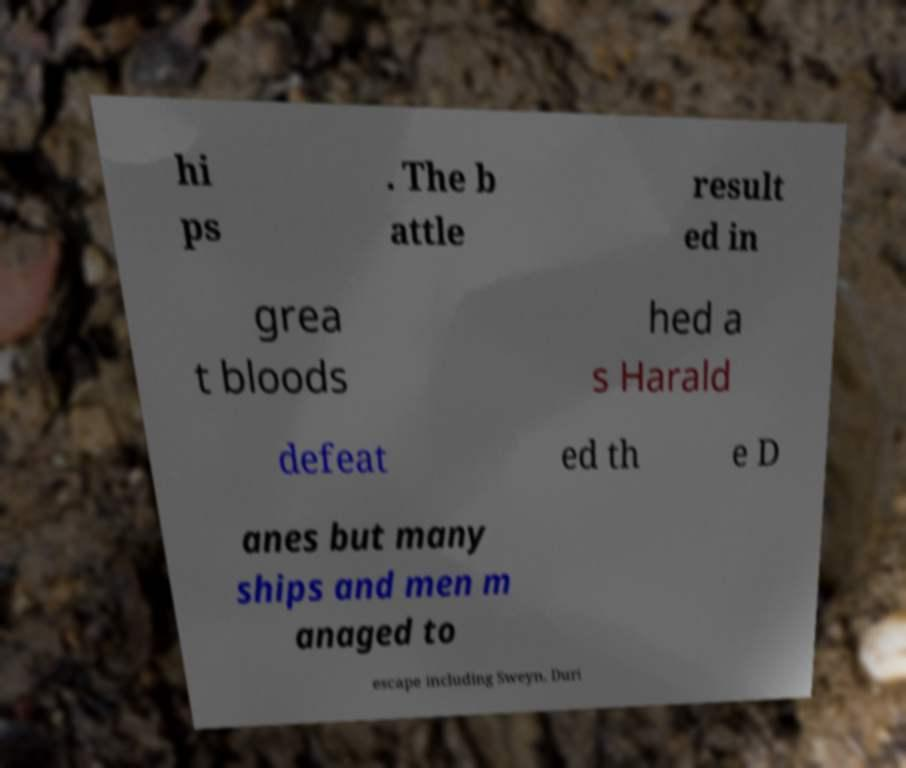What messages or text are displayed in this image? I need them in a readable, typed format. hi ps . The b attle result ed in grea t bloods hed a s Harald defeat ed th e D anes but many ships and men m anaged to escape including Sweyn. Duri 